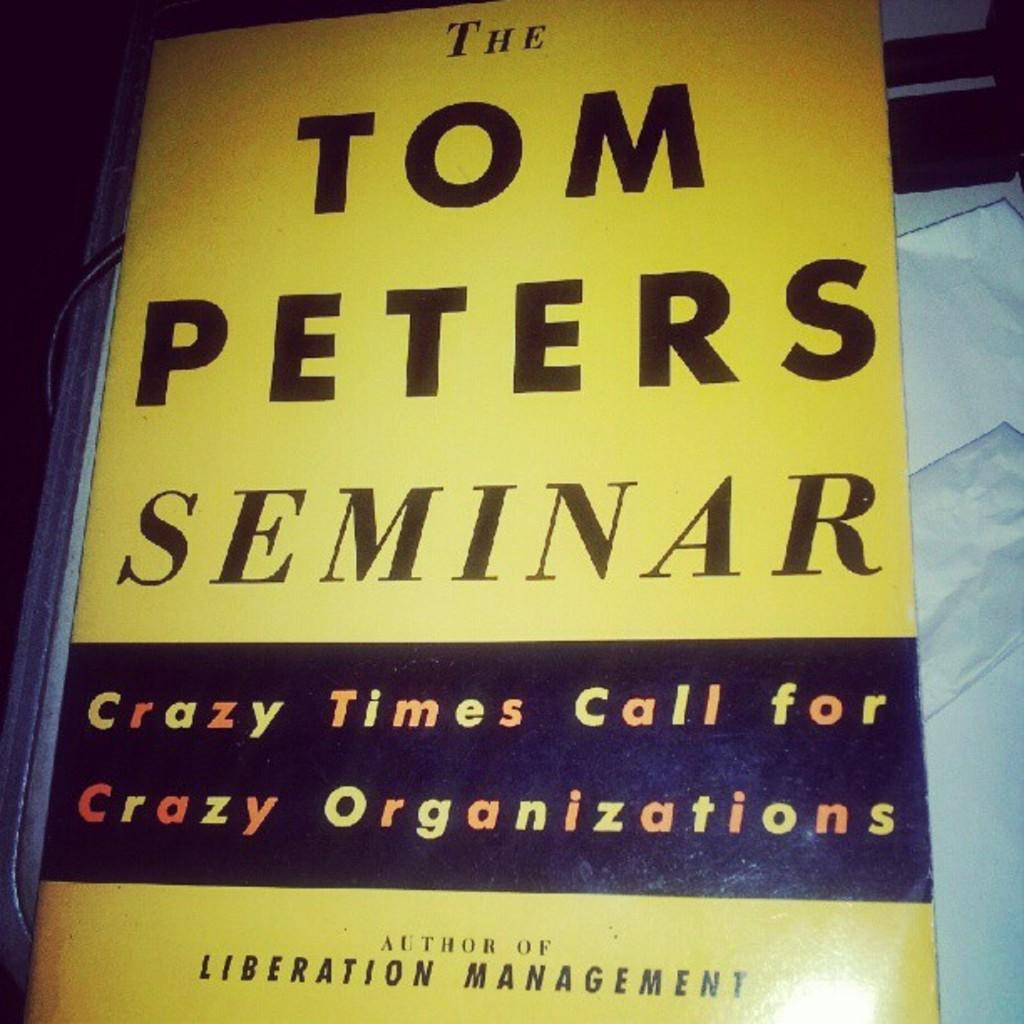<image>
Summarize the visual content of the image. The book cover for the Tom Peters Seminar, it has black text on a yellow background 